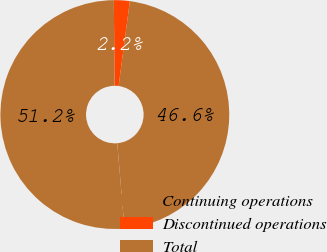<chart> <loc_0><loc_0><loc_500><loc_500><pie_chart><fcel>Continuing operations<fcel>Discontinued operations<fcel>Total<nl><fcel>46.55%<fcel>2.23%<fcel>51.21%<nl></chart> 